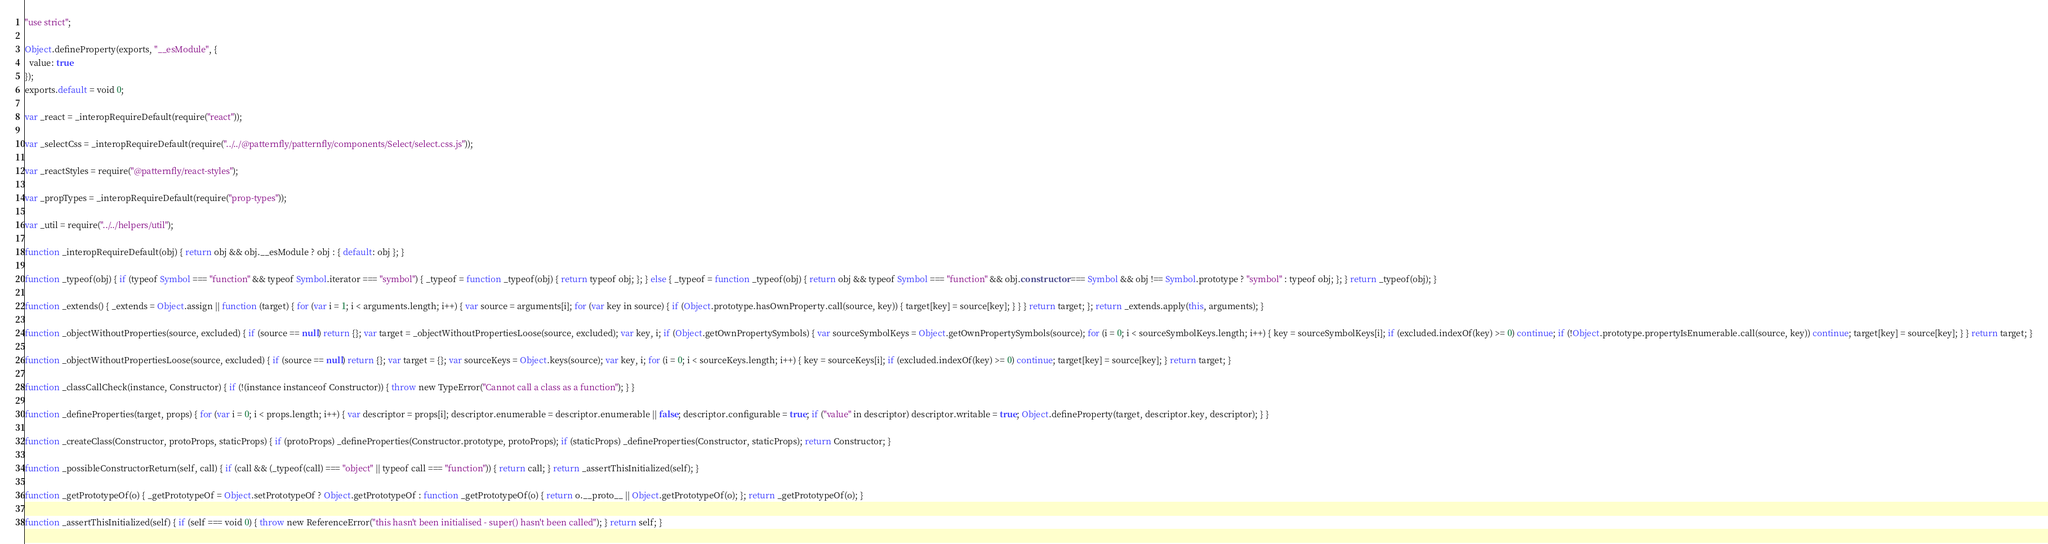Convert code to text. <code><loc_0><loc_0><loc_500><loc_500><_JavaScript_>"use strict";

Object.defineProperty(exports, "__esModule", {
  value: true
});
exports.default = void 0;

var _react = _interopRequireDefault(require("react"));

var _selectCss = _interopRequireDefault(require("../../@patternfly/patternfly/components/Select/select.css.js"));

var _reactStyles = require("@patternfly/react-styles");

var _propTypes = _interopRequireDefault(require("prop-types"));

var _util = require("../../helpers/util");

function _interopRequireDefault(obj) { return obj && obj.__esModule ? obj : { default: obj }; }

function _typeof(obj) { if (typeof Symbol === "function" && typeof Symbol.iterator === "symbol") { _typeof = function _typeof(obj) { return typeof obj; }; } else { _typeof = function _typeof(obj) { return obj && typeof Symbol === "function" && obj.constructor === Symbol && obj !== Symbol.prototype ? "symbol" : typeof obj; }; } return _typeof(obj); }

function _extends() { _extends = Object.assign || function (target) { for (var i = 1; i < arguments.length; i++) { var source = arguments[i]; for (var key in source) { if (Object.prototype.hasOwnProperty.call(source, key)) { target[key] = source[key]; } } } return target; }; return _extends.apply(this, arguments); }

function _objectWithoutProperties(source, excluded) { if (source == null) return {}; var target = _objectWithoutPropertiesLoose(source, excluded); var key, i; if (Object.getOwnPropertySymbols) { var sourceSymbolKeys = Object.getOwnPropertySymbols(source); for (i = 0; i < sourceSymbolKeys.length; i++) { key = sourceSymbolKeys[i]; if (excluded.indexOf(key) >= 0) continue; if (!Object.prototype.propertyIsEnumerable.call(source, key)) continue; target[key] = source[key]; } } return target; }

function _objectWithoutPropertiesLoose(source, excluded) { if (source == null) return {}; var target = {}; var sourceKeys = Object.keys(source); var key, i; for (i = 0; i < sourceKeys.length; i++) { key = sourceKeys[i]; if (excluded.indexOf(key) >= 0) continue; target[key] = source[key]; } return target; }

function _classCallCheck(instance, Constructor) { if (!(instance instanceof Constructor)) { throw new TypeError("Cannot call a class as a function"); } }

function _defineProperties(target, props) { for (var i = 0; i < props.length; i++) { var descriptor = props[i]; descriptor.enumerable = descriptor.enumerable || false; descriptor.configurable = true; if ("value" in descriptor) descriptor.writable = true; Object.defineProperty(target, descriptor.key, descriptor); } }

function _createClass(Constructor, protoProps, staticProps) { if (protoProps) _defineProperties(Constructor.prototype, protoProps); if (staticProps) _defineProperties(Constructor, staticProps); return Constructor; }

function _possibleConstructorReturn(self, call) { if (call && (_typeof(call) === "object" || typeof call === "function")) { return call; } return _assertThisInitialized(self); }

function _getPrototypeOf(o) { _getPrototypeOf = Object.setPrototypeOf ? Object.getPrototypeOf : function _getPrototypeOf(o) { return o.__proto__ || Object.getPrototypeOf(o); }; return _getPrototypeOf(o); }

function _assertThisInitialized(self) { if (self === void 0) { throw new ReferenceError("this hasn't been initialised - super() hasn't been called"); } return self; }
</code> 